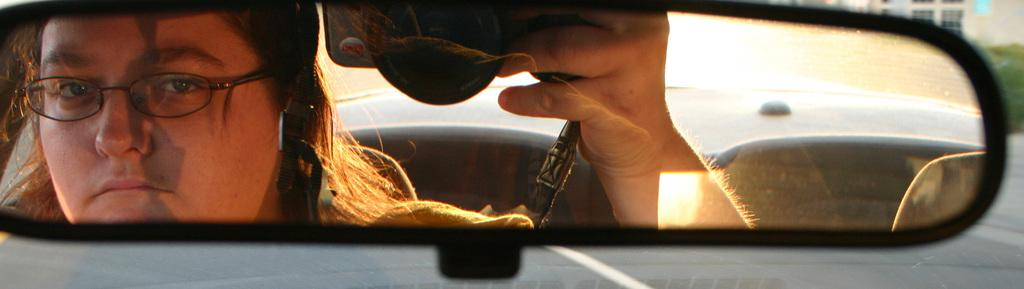What is the person in the car doing? The person is sitting in the car and looking in the front mirror. What object is the person holding in her hand? The person is holding a mobile phone in her hand. What type of sand can be seen in the image? There is no sand present in the image; it features a person sitting in a car. What kind of dogs are visible in the image? There are no dogs present in the image; it features a person sitting in a car. 